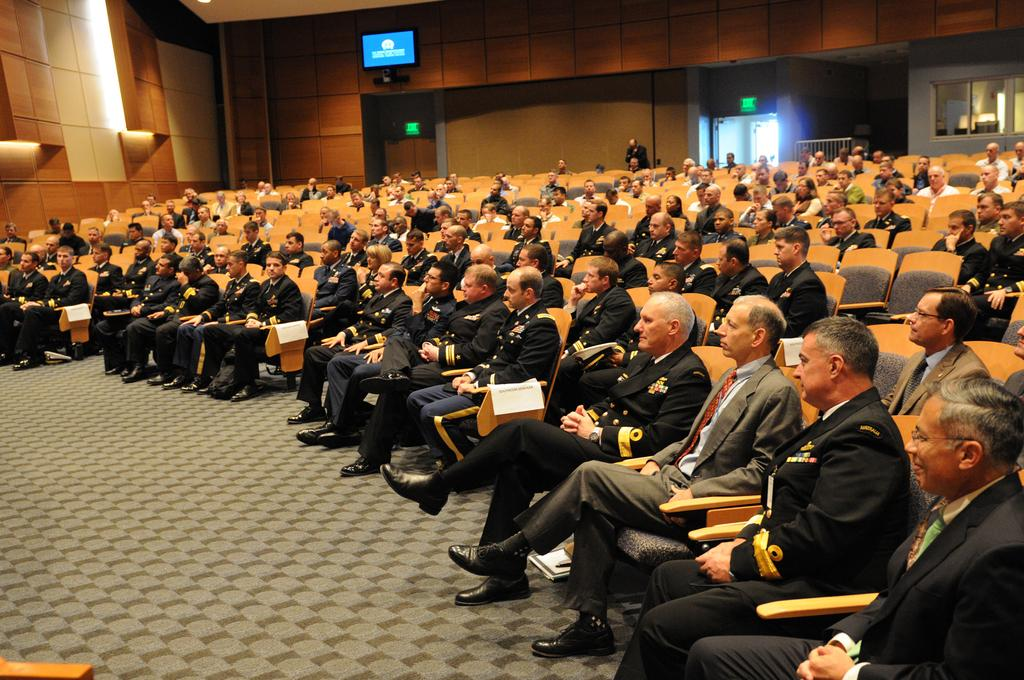What are the people in the image doing? The people in the image are sitting in chairs. Can you describe the background of the image? There is a person standing, a wall, a television screen, and a glass window in the background of the image. How many people are visible in the image? There are at least two people visible in the image, one sitting and one standing. What type of jellyfish can be seen swimming in the glass window in the image? There are no jellyfish present in the image, and the glass window does not show any underwater scenes. 